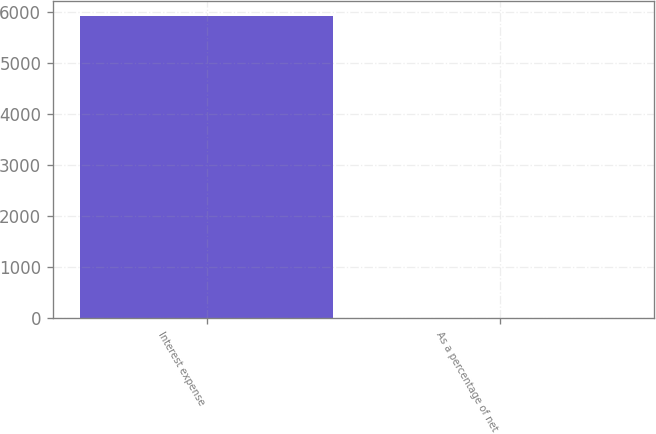Convert chart to OTSL. <chart><loc_0><loc_0><loc_500><loc_500><bar_chart><fcel>Interest expense<fcel>As a percentage of net<nl><fcel>5916<fcel>0.1<nl></chart> 